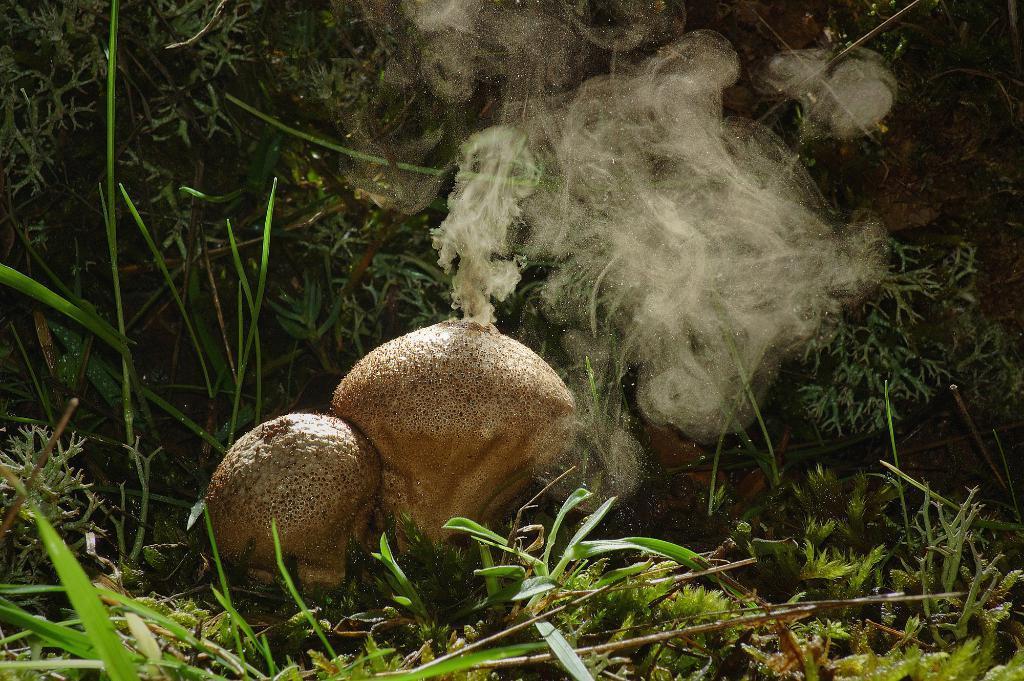Please provide a concise description of this image. In this image I can see some grass on the ground and I can see two brown colored objects on the ground through which I can see smoke is coming out. In the background I can see few plants which are green in color. 